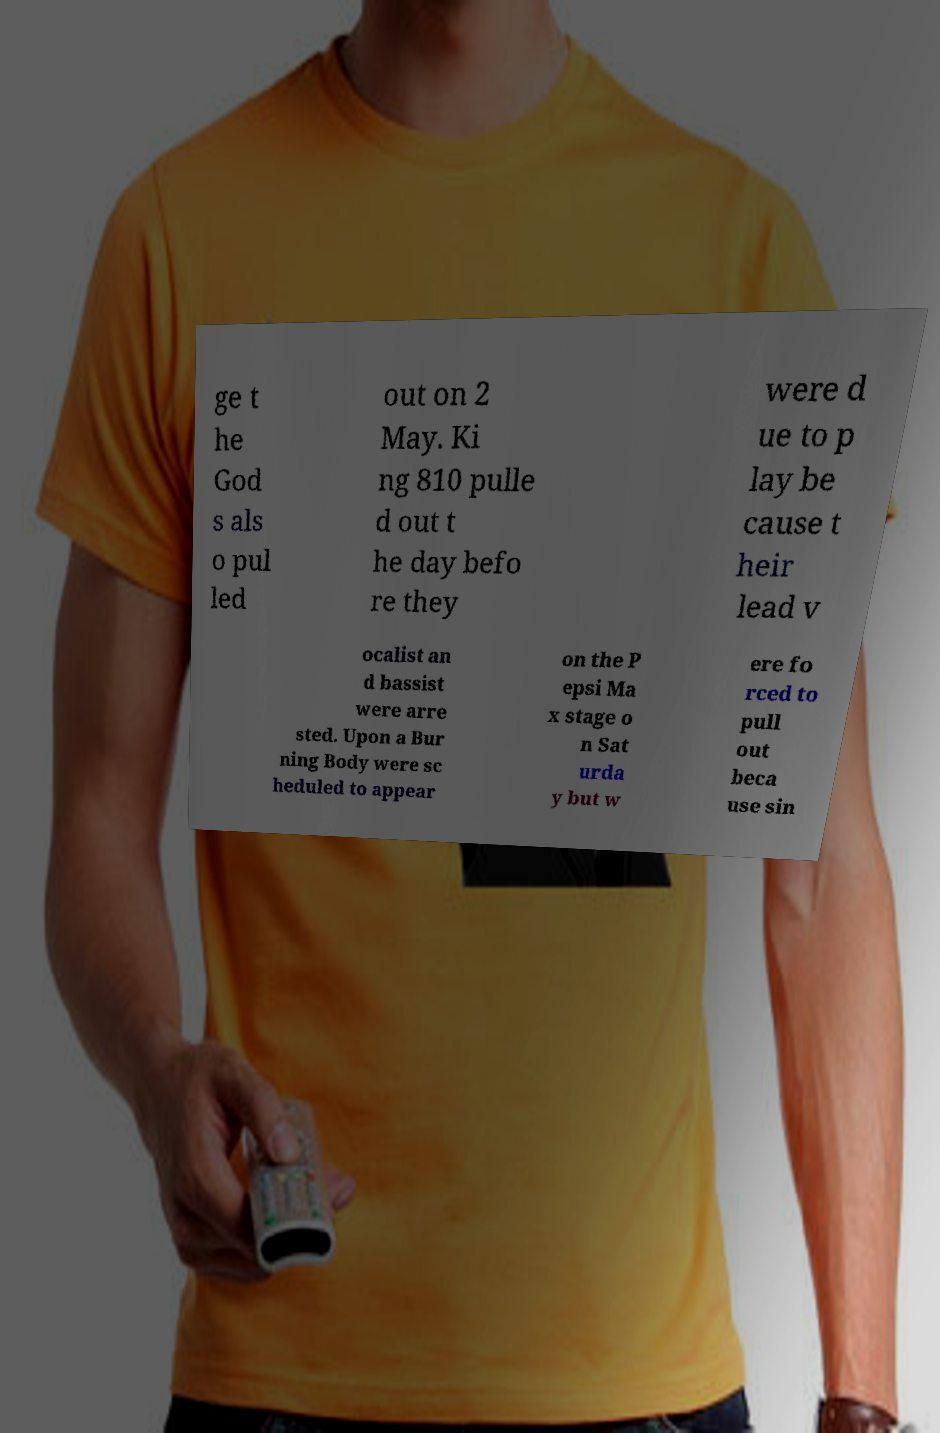I need the written content from this picture converted into text. Can you do that? ge t he God s als o pul led out on 2 May. Ki ng 810 pulle d out t he day befo re they were d ue to p lay be cause t heir lead v ocalist an d bassist were arre sted. Upon a Bur ning Body were sc heduled to appear on the P epsi Ma x stage o n Sat urda y but w ere fo rced to pull out beca use sin 